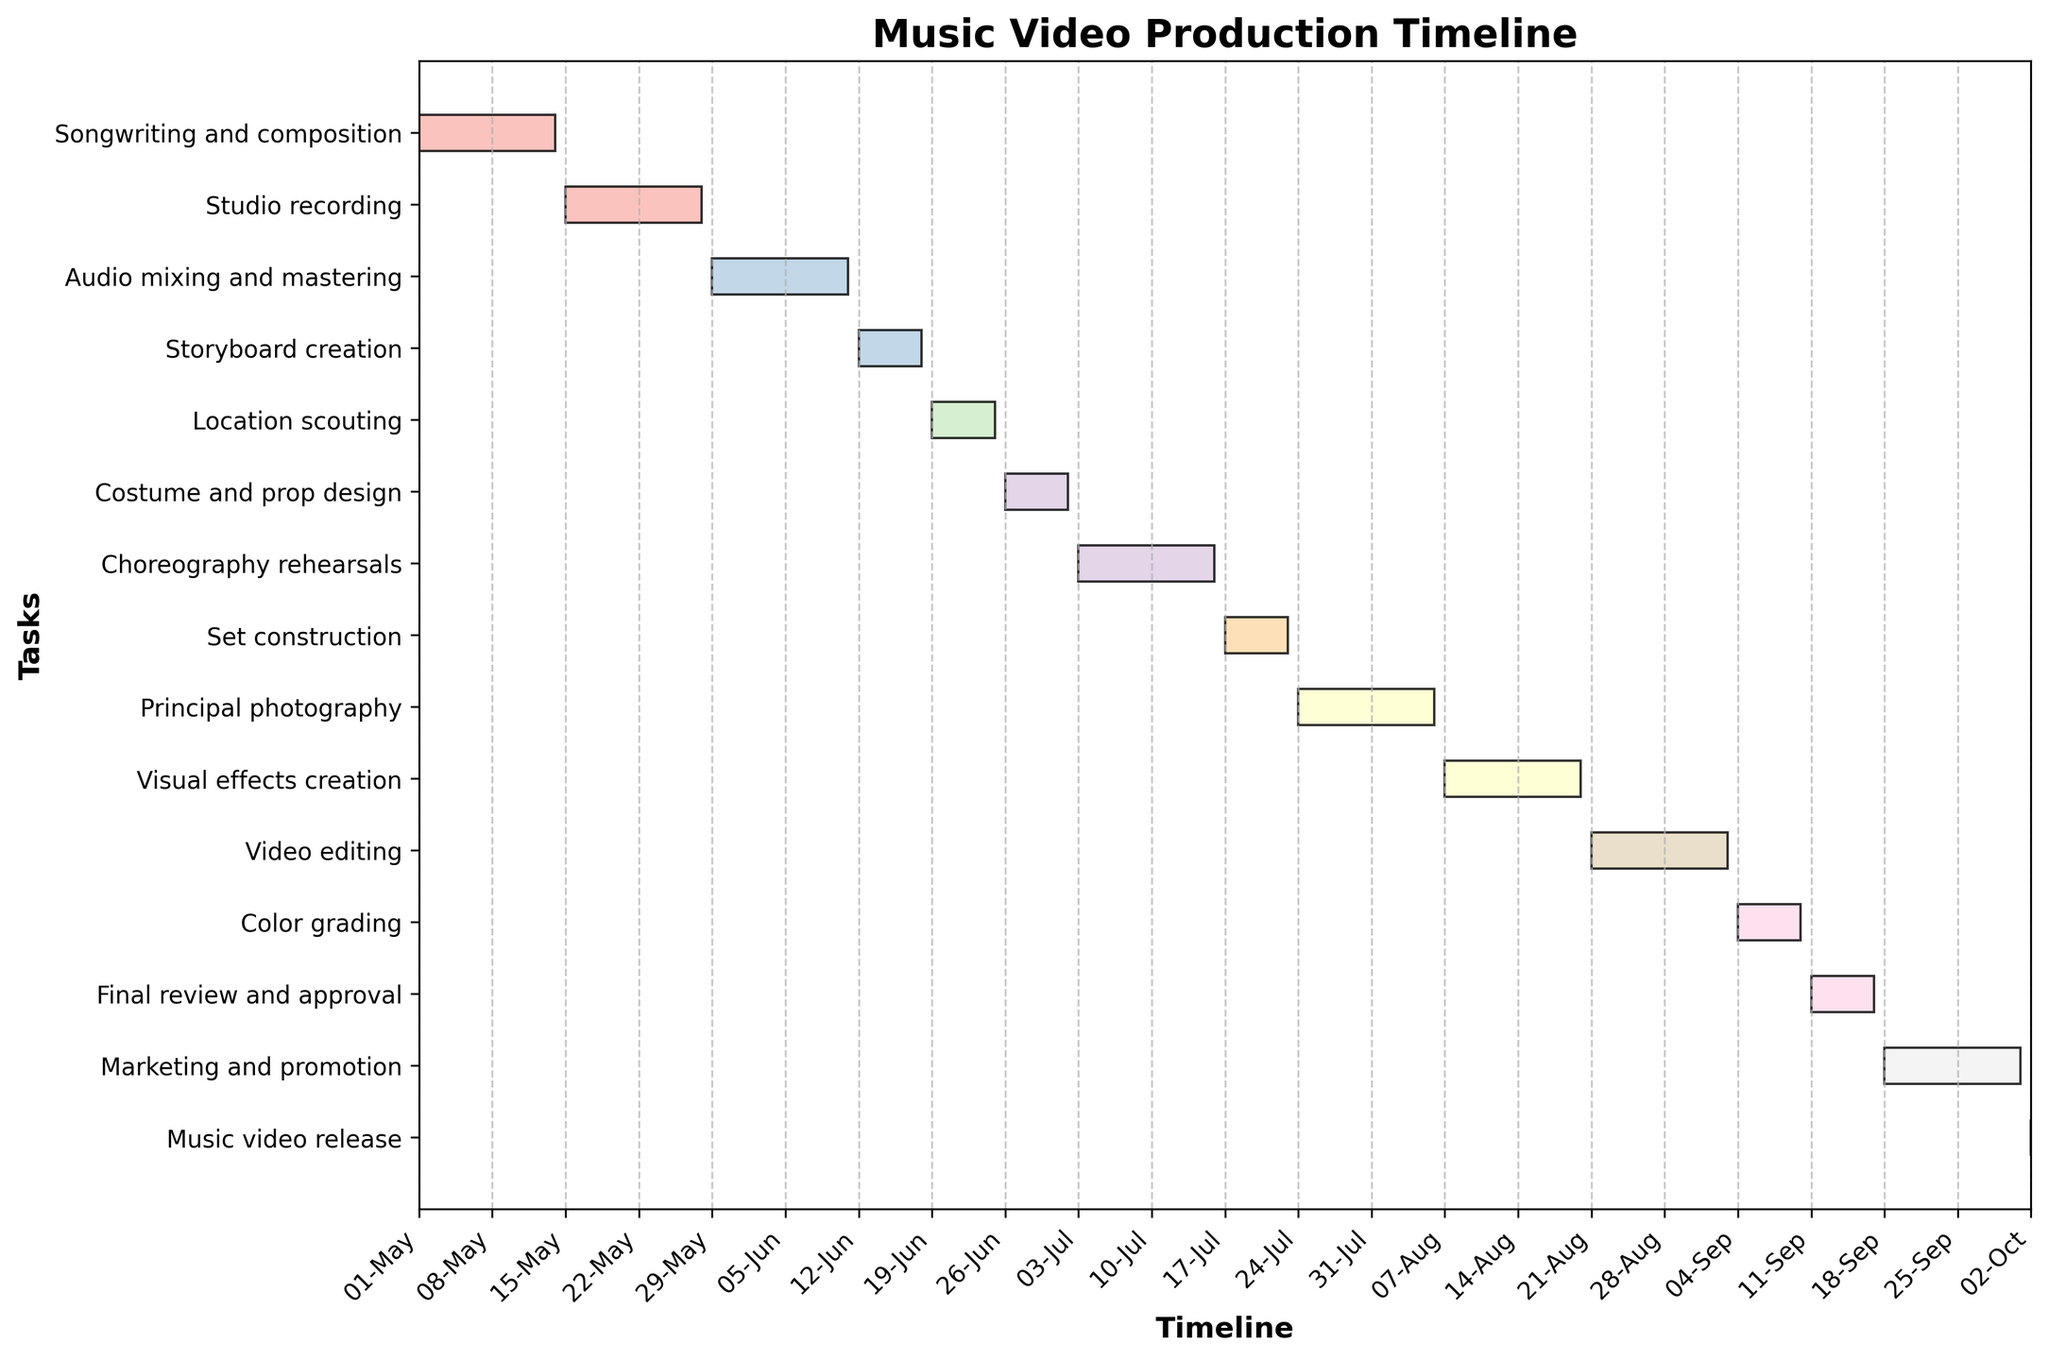What is the title of the Gantt chart? The title of a chart is usually found at the top center of the plot. Here, it clearly says 'Music Video Production Timeline'.
Answer: Music Video Production Timeline During which dates does the 'Principal photography' stage occur? To find this information, look for the 'Principal photography' task in the vertical axis and trace it horizontally to identify the date range from the start to the end of its corresponding bar.
Answer: 2023-07-24 to 2023-08-06 Which stage comes immediately after 'Location scouting'? Locate the 'Location scouting' task, then check the task listed immediately below it in the vertical axis to determine which task follows directly after.
Answer: Costume and prop design How long does the 'Audio mixing and mastering' stage last? By examining the horizontal length of the 'Audio mixing and mastering' bar and noting its start and end dates, you can calculate the duration by counting the days between these dates.
Answer: 14 days What is the total duration of the 'Studio recording' stage in days? Look for the 'Studio recording' task and note its start and end dates. Calculate the total duration by finding the difference in days between these two dates.
Answer: 14 days Compare the duration of 'Choreography rehearsals' and 'Set construction'. Which one takes longer, and by how many days? First, identify the duration of 'Choreography rehearsals' and 'Set construction' by analyzing the length of their respective bars. Then, compute the difference in their durations.
Answer: Choreography rehearsals takes longer by 7 days Which tasks are scheduled to end in the month of September? Determine the tasks that have ending dates falling within the range of September 1 to September 30 by examining the end dates of each task listed.
Answer: Color grading, Final review and approval How many days is the 'Marketing and promotion' stage scheduled for? To compute this, locate the 'Marketing and promotion' task and calculate the duration from its start date to its end date.
Answer: 14 days What is the final task before the 'Music video release'? Locate the 'Music video release' task and identify the task listed immediately above it in the vertical axis.
Answer: Marketing and promotion Which stage involves the creation of the storyboard for the music video? Find the task with the name 'Storyboard creation' in the vertical axis to determine which stage is responsible for creating the storyboard.
Answer: Storyboard creation 